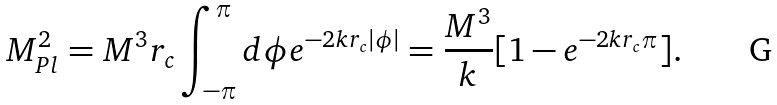<formula> <loc_0><loc_0><loc_500><loc_500>M _ { P l } ^ { 2 } = M ^ { 3 } r _ { c } \int _ { - \pi } ^ { \pi } d \phi e ^ { - 2 k r _ { c } | \phi | } = \frac { M ^ { 3 } } { k } [ 1 - e ^ { - 2 k r _ { c } \pi } ] .</formula> 